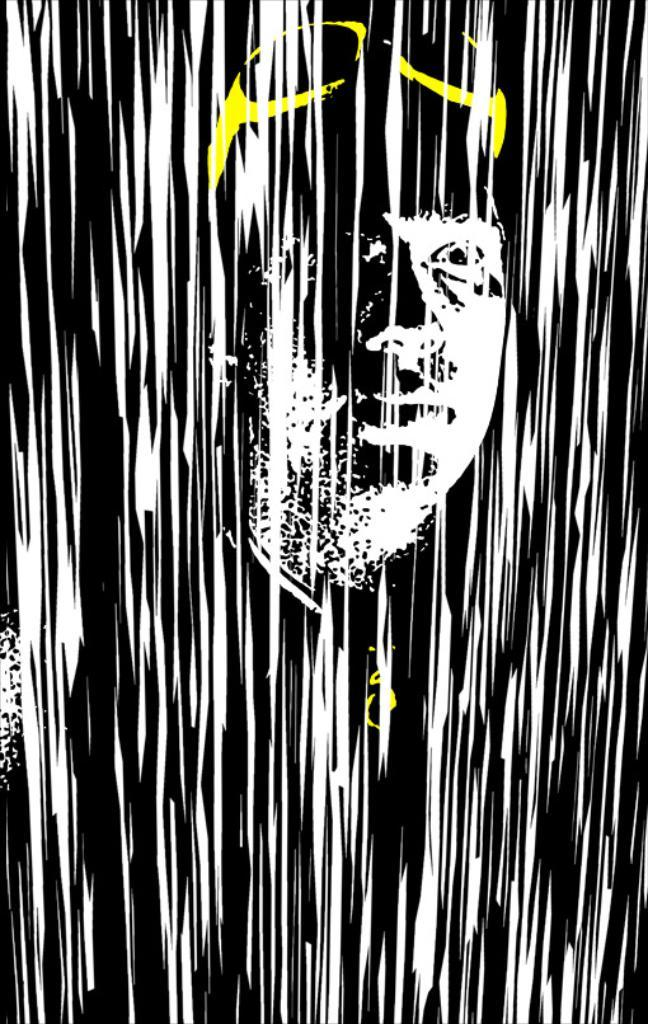What is depicted in the image? There is a representation of a man in the image. How is the man depicted in the image? The representation of the man is in an animated or illustrative style. What type of zinc is used to create the man's representation in the image? There is no mention of zinc being used in the image, as the representation of the man is in an animated or illustrative style. How comfortable is the man's representation in the image? The comfort of the man's representation cannot be determined from the image, as it is an illustration and not a real person. 